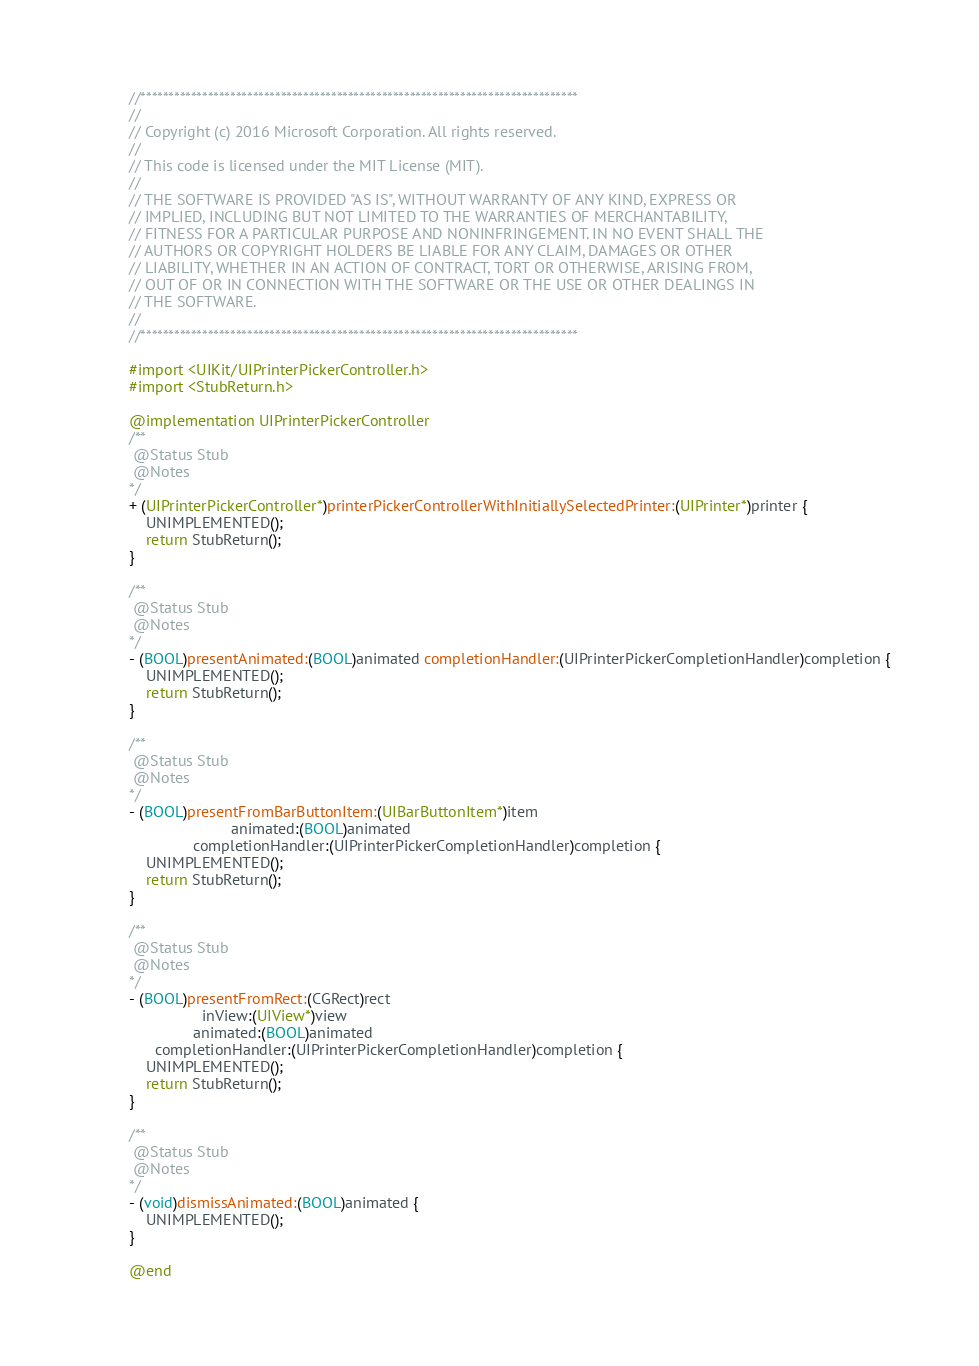<code> <loc_0><loc_0><loc_500><loc_500><_ObjectiveC_>//******************************************************************************
//
// Copyright (c) 2016 Microsoft Corporation. All rights reserved.
//
// This code is licensed under the MIT License (MIT).
//
// THE SOFTWARE IS PROVIDED "AS IS", WITHOUT WARRANTY OF ANY KIND, EXPRESS OR
// IMPLIED, INCLUDING BUT NOT LIMITED TO THE WARRANTIES OF MERCHANTABILITY,
// FITNESS FOR A PARTICULAR PURPOSE AND NONINFRINGEMENT. IN NO EVENT SHALL THE
// AUTHORS OR COPYRIGHT HOLDERS BE LIABLE FOR ANY CLAIM, DAMAGES OR OTHER
// LIABILITY, WHETHER IN AN ACTION OF CONTRACT, TORT OR OTHERWISE, ARISING FROM,
// OUT OF OR IN CONNECTION WITH THE SOFTWARE OR THE USE OR OTHER DEALINGS IN
// THE SOFTWARE.
//
//******************************************************************************

#import <UIKit/UIPrinterPickerController.h>
#import <StubReturn.h>

@implementation UIPrinterPickerController
/**
 @Status Stub
 @Notes
*/
+ (UIPrinterPickerController*)printerPickerControllerWithInitiallySelectedPrinter:(UIPrinter*)printer {
    UNIMPLEMENTED();
    return StubReturn();
}

/**
 @Status Stub
 @Notes
*/
- (BOOL)presentAnimated:(BOOL)animated completionHandler:(UIPrinterPickerCompletionHandler)completion {
    UNIMPLEMENTED();
    return StubReturn();
}

/**
 @Status Stub
 @Notes
*/
- (BOOL)presentFromBarButtonItem:(UIBarButtonItem*)item
                        animated:(BOOL)animated
               completionHandler:(UIPrinterPickerCompletionHandler)completion {
    UNIMPLEMENTED();
    return StubReturn();
}

/**
 @Status Stub
 @Notes
*/
- (BOOL)presentFromRect:(CGRect)rect
                 inView:(UIView*)view
               animated:(BOOL)animated
      completionHandler:(UIPrinterPickerCompletionHandler)completion {
    UNIMPLEMENTED();
    return StubReturn();
}

/**
 @Status Stub
 @Notes
*/
- (void)dismissAnimated:(BOOL)animated {
    UNIMPLEMENTED();
}

@end
</code> 